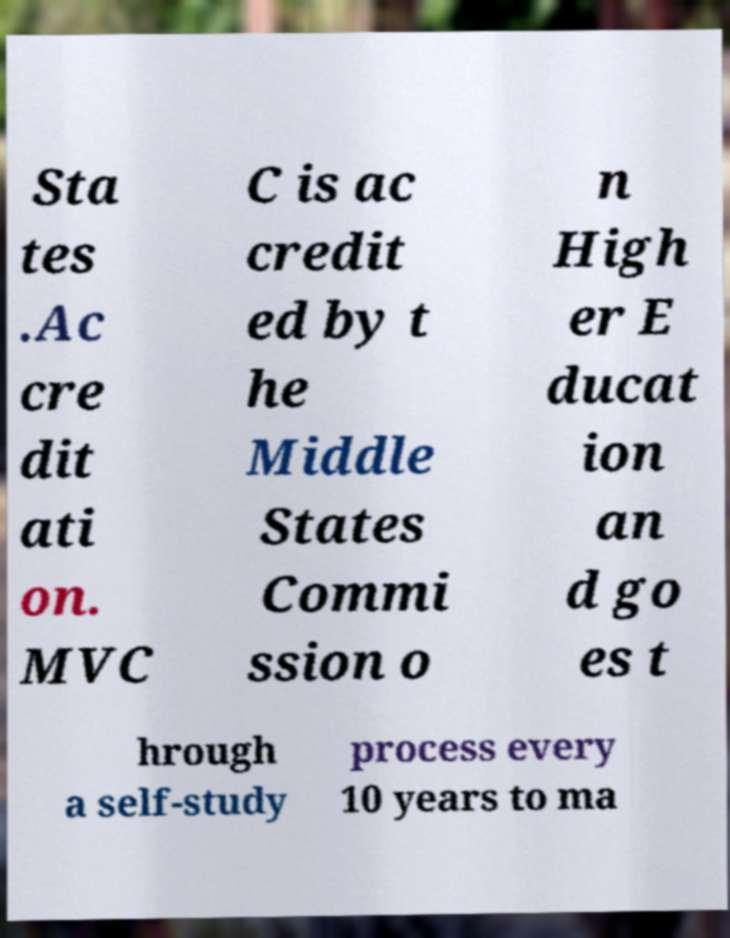I need the written content from this picture converted into text. Can you do that? Sta tes .Ac cre dit ati on. MVC C is ac credit ed by t he Middle States Commi ssion o n High er E ducat ion an d go es t hrough a self-study process every 10 years to ma 